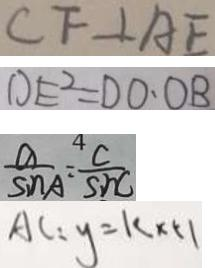Convert formula to latex. <formula><loc_0><loc_0><loc_500><loc_500>C F \bot A E 
 D E ^ { 2 } = D O \cdot O B 
 \frac { a } { \sin A } = \frac { C } { \sin C } 
 A C : y = k \times 5 1</formula> 